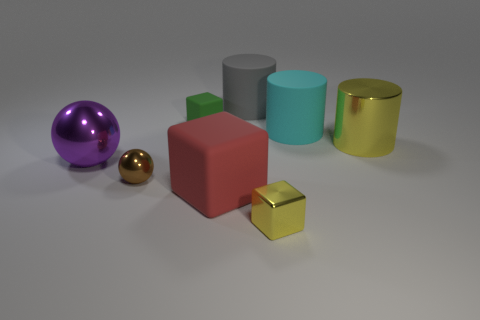There is a metallic thing that is the same color as the large shiny cylinder; what is its shape?
Your response must be concise. Cube. What color is the large rubber object that is both behind the purple sphere and on the left side of the cyan object?
Provide a succinct answer. Gray. Do the gray matte thing and the purple object have the same size?
Provide a short and direct response. Yes. What is the color of the big matte cylinder that is left of the tiny yellow metallic cube?
Keep it short and to the point. Gray. Is there a tiny metallic cube that has the same color as the shiny cylinder?
Offer a terse response. Yes. What color is the other metal object that is the same size as the brown shiny object?
Your response must be concise. Yellow. Is the shape of the brown thing the same as the big purple thing?
Offer a very short reply. Yes. There is a small cube behind the shiny cylinder; what material is it?
Offer a terse response. Rubber. What color is the big metallic sphere?
Make the answer very short. Purple. There is a rubber object in front of the metallic cylinder; is its size the same as the rubber object behind the green thing?
Your answer should be compact. Yes. 